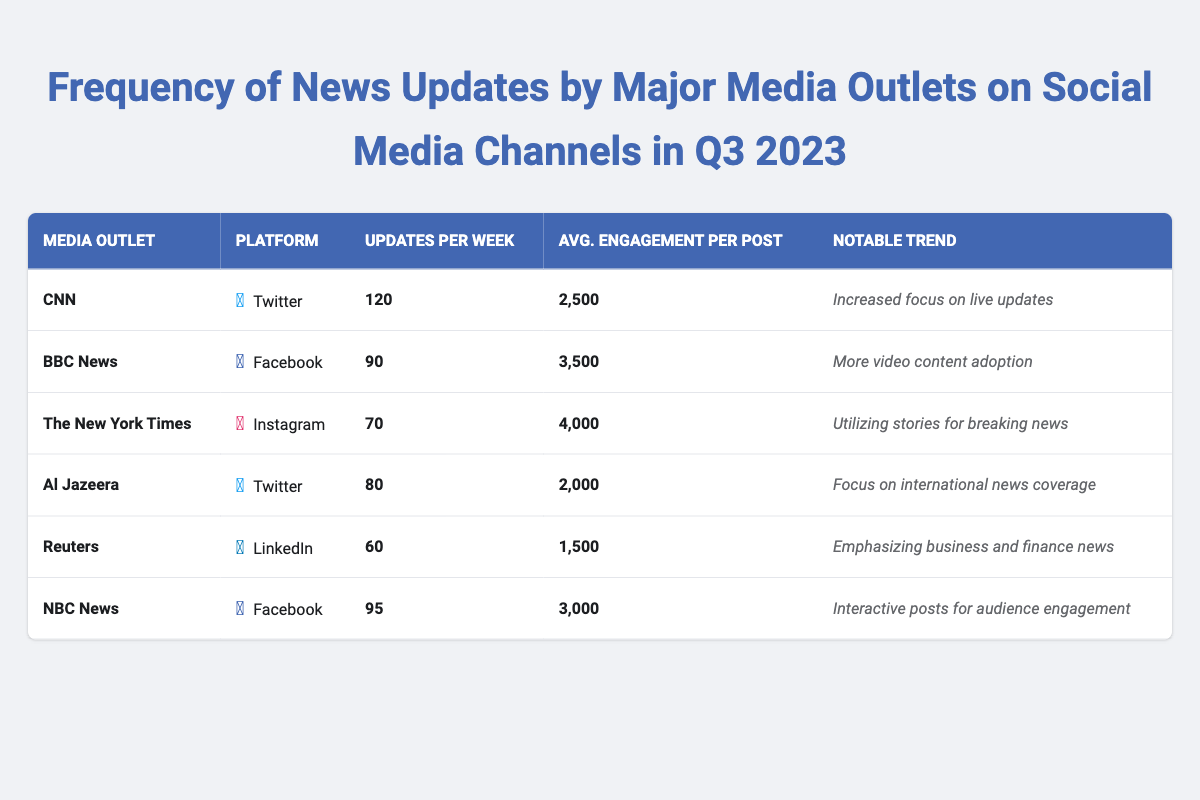What media outlet has the highest updates per week? Looking at the table, CNN has the highest updates with 120 updates per week, compared to other outlets.
Answer: CNN How many updates per week does Reuters provide? The table shows that Reuters provides 60 updates per week.
Answer: 60 Which platform has the maximum average engagement per post? From the table, Instagram (The New York Times) has the maximum average engagement at 4000 per post.
Answer: Instagram What is the total number of updates per week from NBC News and BBC News combined? Adding both NBC News (95 updates) and BBC News (90 updates), we get 95 + 90 = 185 updates per week.
Answer: 185 Is it true that Al Jazeera has a higher engagement per post than CNN? According to the table, Al Jazeera's engagement is 2000 per post, which is less than CNN’s engagement of 2500 per post. Therefore, this statement is false.
Answer: No What is the average number of updates per week across all the media outlets listed? The updates per week are 120 (CNN) + 90 (BBC News) + 70 (The New York Times) + 80 (Al Jazeera) + 60 (Reuters) + 95 (NBC News) = 515 in total. There are 6 outlets, so the average is 515 / 6 = 85.83, approximately 86 updates per week.
Answer: 86 Which media outlet has the lowest updates and what is the notable trend associated with it? Reviewing the table, Reuters has the lowest updates with 60 per week. Its notable trend is emphasizing business and finance news.
Answer: Reuters, emphasizing business and finance news What is the difference in average engagement per post between BBC News and NBC News? BBC News has an average engagement of 3500, while NBC News has 3000. The difference is 3500 - 3000 = 500 engagements.
Answer: 500 Which two media outlets focus on social media channels intended for international and business news? Al Jazeera on Twitter focuses on international news, while Reuters on LinkedIn emphasizes business and finance news, as stated in the table.
Answer: Al Jazeera and Reuters What notable trend is associated with The New York Times? The table mentions that The New York Times utilizes stories for breaking news as its notable trend.
Answer: Utilizing stories for breaking news 